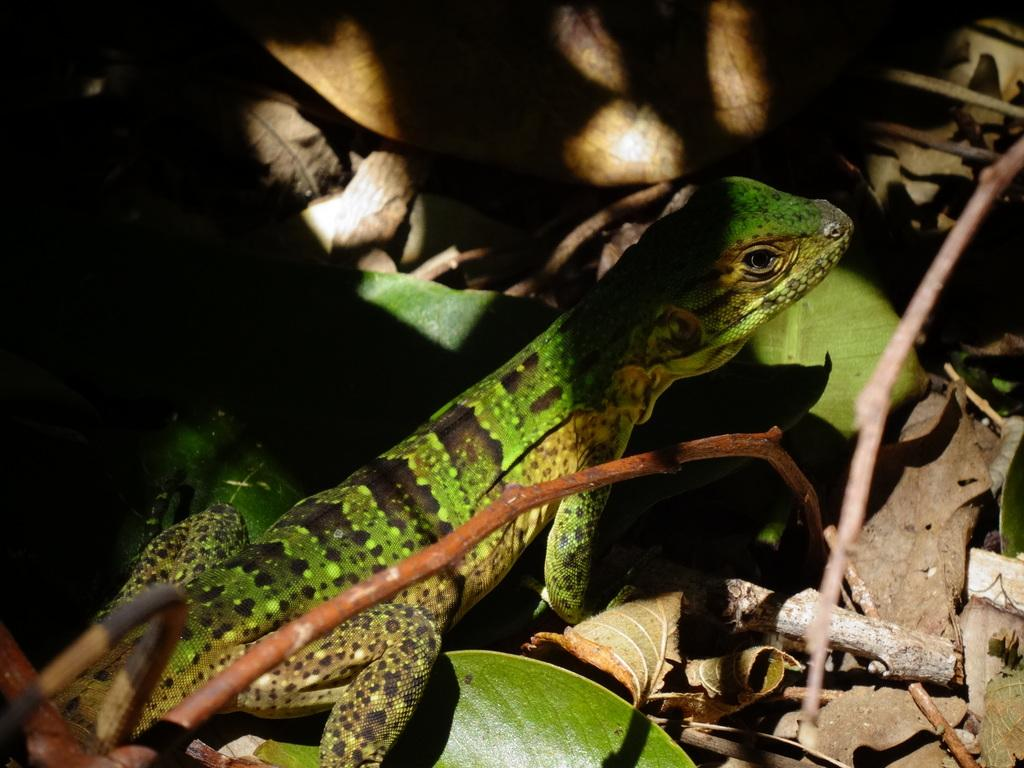What type of animal is in the image? There is a green reptile in the image. What is the reptile standing on? The reptile is standing on leaves. What can be seen in the background of the image? There is a wall in the background of the image. How many horses are visible in the image? There are no horses present in the image; it features a green reptile standing on leaves with a wall in the background. 